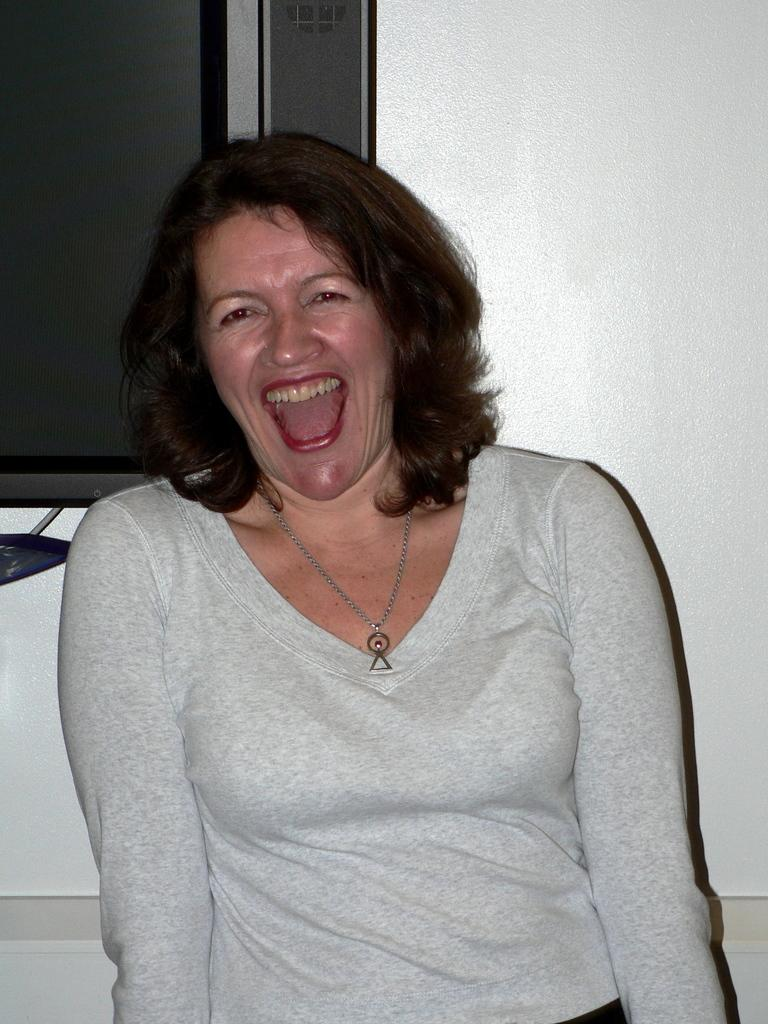Who is present in the image? There is a woman in the image. What electronic device is visible in the image? There is a television visible in the image. What type of architectural feature can be seen in the image? There is a wall in the image. What type of prose is the woman reading from in the image? There is no indication in the image that the woman is reading any prose. What is the weight of the television in the image? The weight of the television cannot be determined from the image. Is there a chain attached to the wall in the image? There is no chain visible in the image. 